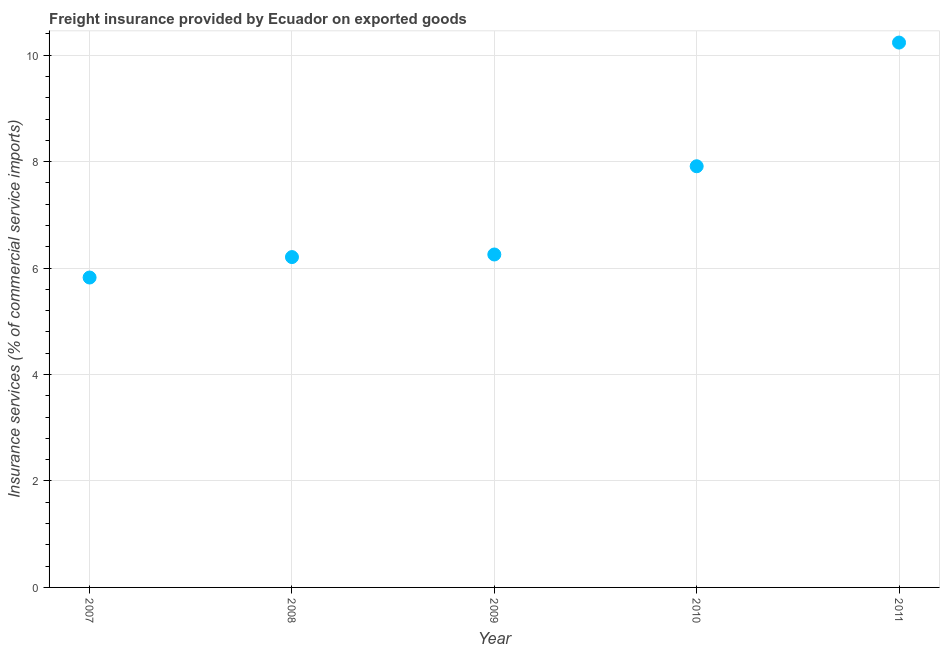What is the freight insurance in 2011?
Provide a succinct answer. 10.24. Across all years, what is the maximum freight insurance?
Provide a short and direct response. 10.24. Across all years, what is the minimum freight insurance?
Your response must be concise. 5.82. In which year was the freight insurance maximum?
Offer a very short reply. 2011. In which year was the freight insurance minimum?
Provide a succinct answer. 2007. What is the sum of the freight insurance?
Give a very brief answer. 36.43. What is the difference between the freight insurance in 2010 and 2011?
Your answer should be very brief. -2.32. What is the average freight insurance per year?
Ensure brevity in your answer.  7.29. What is the median freight insurance?
Keep it short and to the point. 6.25. Do a majority of the years between 2010 and 2007 (inclusive) have freight insurance greater than 10 %?
Give a very brief answer. Yes. What is the ratio of the freight insurance in 2007 to that in 2008?
Your answer should be very brief. 0.94. Is the freight insurance in 2010 less than that in 2011?
Give a very brief answer. Yes. What is the difference between the highest and the second highest freight insurance?
Provide a succinct answer. 2.32. Is the sum of the freight insurance in 2007 and 2009 greater than the maximum freight insurance across all years?
Provide a short and direct response. Yes. What is the difference between the highest and the lowest freight insurance?
Ensure brevity in your answer.  4.41. In how many years, is the freight insurance greater than the average freight insurance taken over all years?
Keep it short and to the point. 2. Does the freight insurance monotonically increase over the years?
Your response must be concise. Yes. Does the graph contain grids?
Keep it short and to the point. Yes. What is the title of the graph?
Offer a terse response. Freight insurance provided by Ecuador on exported goods . What is the label or title of the Y-axis?
Your response must be concise. Insurance services (% of commercial service imports). What is the Insurance services (% of commercial service imports) in 2007?
Make the answer very short. 5.82. What is the Insurance services (% of commercial service imports) in 2008?
Your answer should be compact. 6.21. What is the Insurance services (% of commercial service imports) in 2009?
Make the answer very short. 6.25. What is the Insurance services (% of commercial service imports) in 2010?
Your answer should be compact. 7.91. What is the Insurance services (% of commercial service imports) in 2011?
Provide a succinct answer. 10.24. What is the difference between the Insurance services (% of commercial service imports) in 2007 and 2008?
Offer a terse response. -0.38. What is the difference between the Insurance services (% of commercial service imports) in 2007 and 2009?
Provide a short and direct response. -0.43. What is the difference between the Insurance services (% of commercial service imports) in 2007 and 2010?
Ensure brevity in your answer.  -2.09. What is the difference between the Insurance services (% of commercial service imports) in 2007 and 2011?
Provide a short and direct response. -4.41. What is the difference between the Insurance services (% of commercial service imports) in 2008 and 2009?
Provide a short and direct response. -0.05. What is the difference between the Insurance services (% of commercial service imports) in 2008 and 2010?
Provide a succinct answer. -1.71. What is the difference between the Insurance services (% of commercial service imports) in 2008 and 2011?
Provide a short and direct response. -4.03. What is the difference between the Insurance services (% of commercial service imports) in 2009 and 2010?
Give a very brief answer. -1.66. What is the difference between the Insurance services (% of commercial service imports) in 2009 and 2011?
Your answer should be compact. -3.98. What is the difference between the Insurance services (% of commercial service imports) in 2010 and 2011?
Keep it short and to the point. -2.32. What is the ratio of the Insurance services (% of commercial service imports) in 2007 to that in 2008?
Your response must be concise. 0.94. What is the ratio of the Insurance services (% of commercial service imports) in 2007 to that in 2010?
Your answer should be compact. 0.74. What is the ratio of the Insurance services (% of commercial service imports) in 2007 to that in 2011?
Your answer should be compact. 0.57. What is the ratio of the Insurance services (% of commercial service imports) in 2008 to that in 2009?
Your answer should be very brief. 0.99. What is the ratio of the Insurance services (% of commercial service imports) in 2008 to that in 2010?
Provide a short and direct response. 0.78. What is the ratio of the Insurance services (% of commercial service imports) in 2008 to that in 2011?
Offer a terse response. 0.61. What is the ratio of the Insurance services (% of commercial service imports) in 2009 to that in 2010?
Your response must be concise. 0.79. What is the ratio of the Insurance services (% of commercial service imports) in 2009 to that in 2011?
Keep it short and to the point. 0.61. What is the ratio of the Insurance services (% of commercial service imports) in 2010 to that in 2011?
Offer a very short reply. 0.77. 